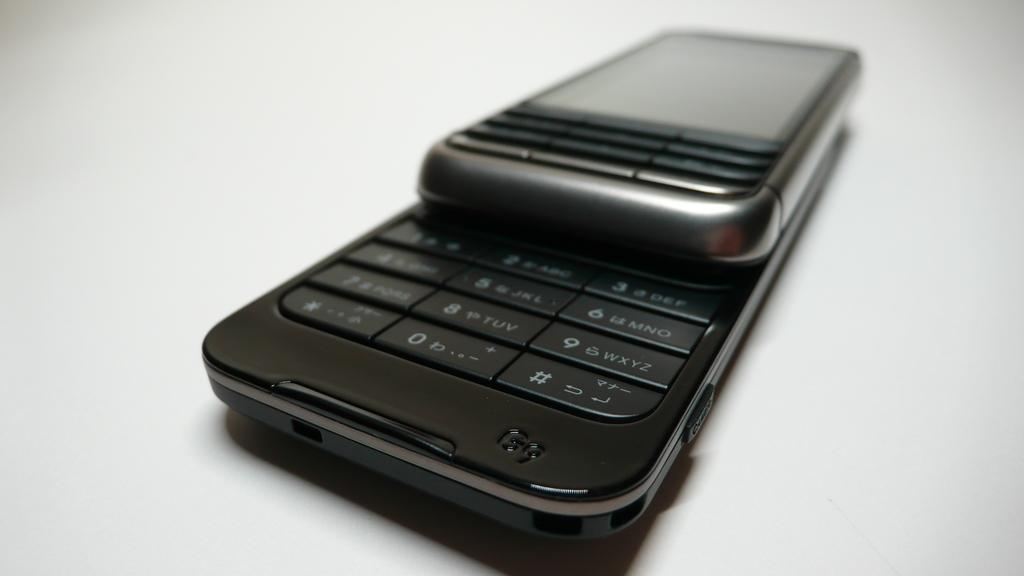<image>
Present a compact description of the photo's key features. A phone slid open to reveal the touch pad with digits 2, 3, and more. 